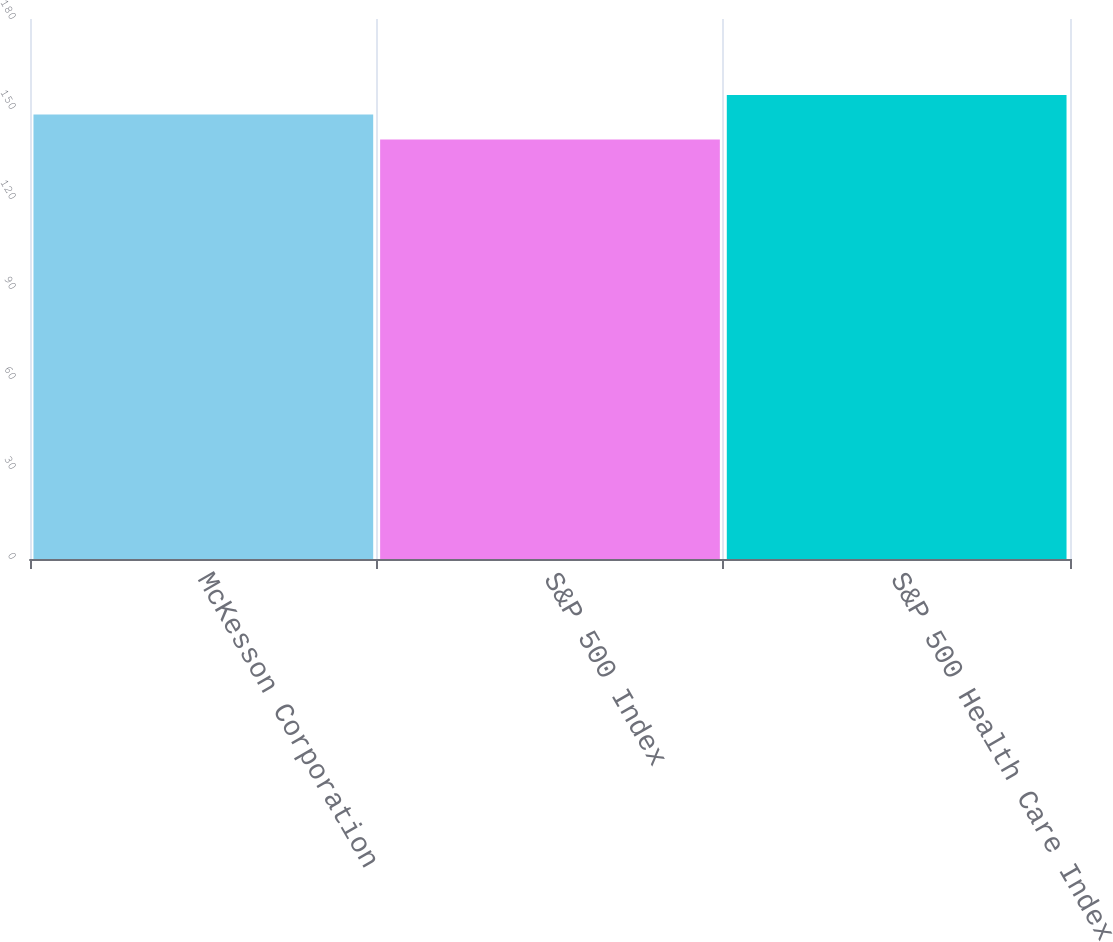<chart> <loc_0><loc_0><loc_500><loc_500><bar_chart><fcel>McKesson Corporation<fcel>S&P 500 Index<fcel>S&P 500 Health Care Index<nl><fcel>148.16<fcel>139.82<fcel>154.64<nl></chart> 